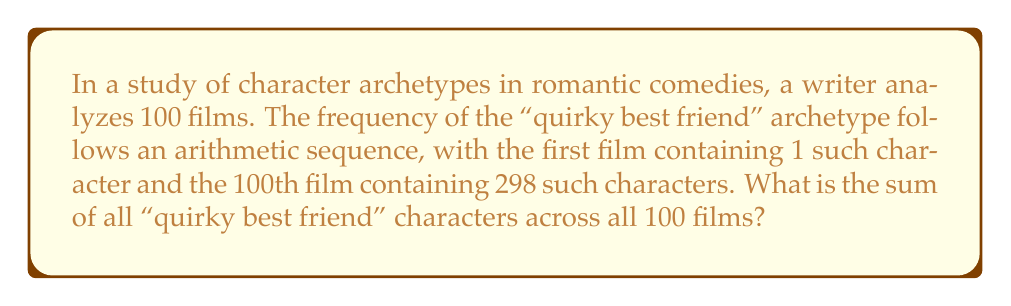Could you help me with this problem? Let's approach this step-by-step:

1) In an arithmetic sequence, the difference between each term is constant. Let's call this common difference $d$.

2) We know the first term $a_1 = 1$ and the 100th term $a_{100} = 298$.

3) For an arithmetic sequence, the nth term is given by:
   $a_n = a_1 + (n-1)d$

4) We can use this to find $d$:
   $298 = 1 + (100-1)d$
   $297 = 99d$
   $d = 3$

5) Now we know the sequence starts at 1 and increases by 3 each time.

6) To find the sum of all terms, we can use the formula for the sum of an arithmetic series:
   $S_n = \frac{n}{2}(a_1 + a_n)$
   where $n$ is the number of terms, $a_1$ is the first term, and $a_n$ is the last term.

7) Plugging in our values:
   $S_{100} = \frac{100}{2}(1 + 298)$
   $S_{100} = 50(299)$
   $S_{100} = 14,950$

Therefore, the sum of all "quirky best friend" characters across all 100 films is 14,950.
Answer: 14,950 